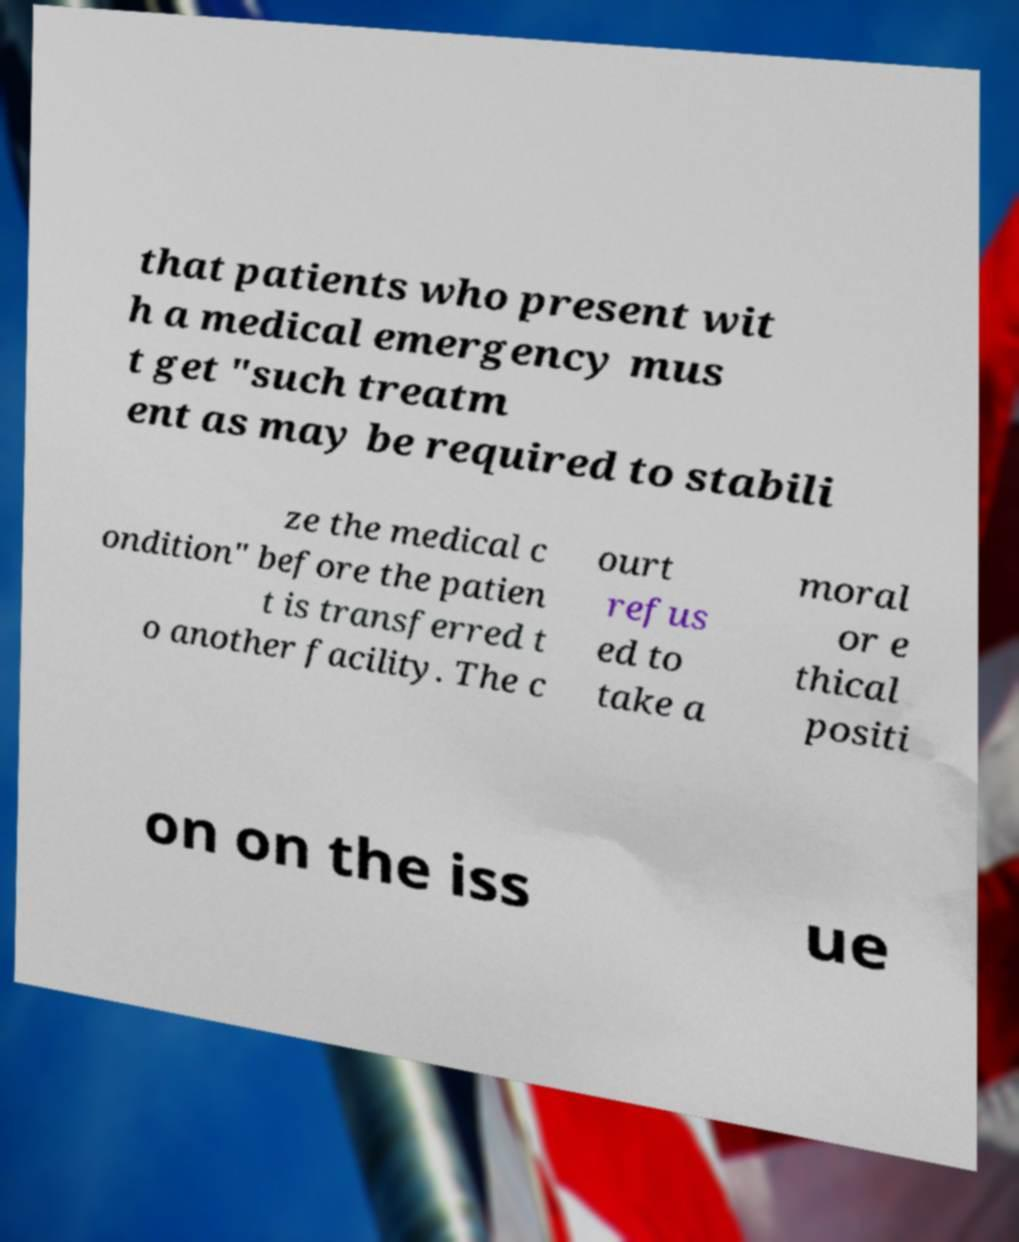Please identify and transcribe the text found in this image. that patients who present wit h a medical emergency mus t get "such treatm ent as may be required to stabili ze the medical c ondition" before the patien t is transferred t o another facility. The c ourt refus ed to take a moral or e thical positi on on the iss ue 